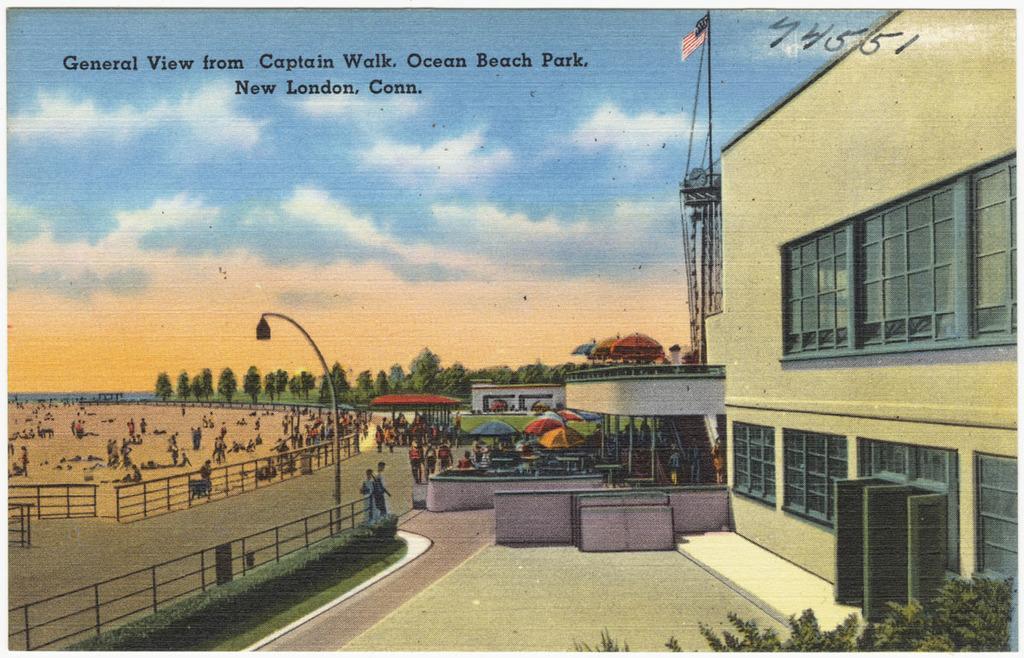Could you give a brief overview of what you see in this image? On the right side there is a building with windows. Near to that there is a shed. On that there is a flag. Also there are umbrellas, railings, bushes. In the background there are many people, trees and sky. 